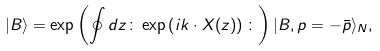<formula> <loc_0><loc_0><loc_500><loc_500>| B \rangle = \exp \left ( \oint d z \colon \exp \left ( i k \cdot X ( z ) \right ) \colon \right ) | B , p = - \bar { p } \rangle _ { N } ,</formula> 